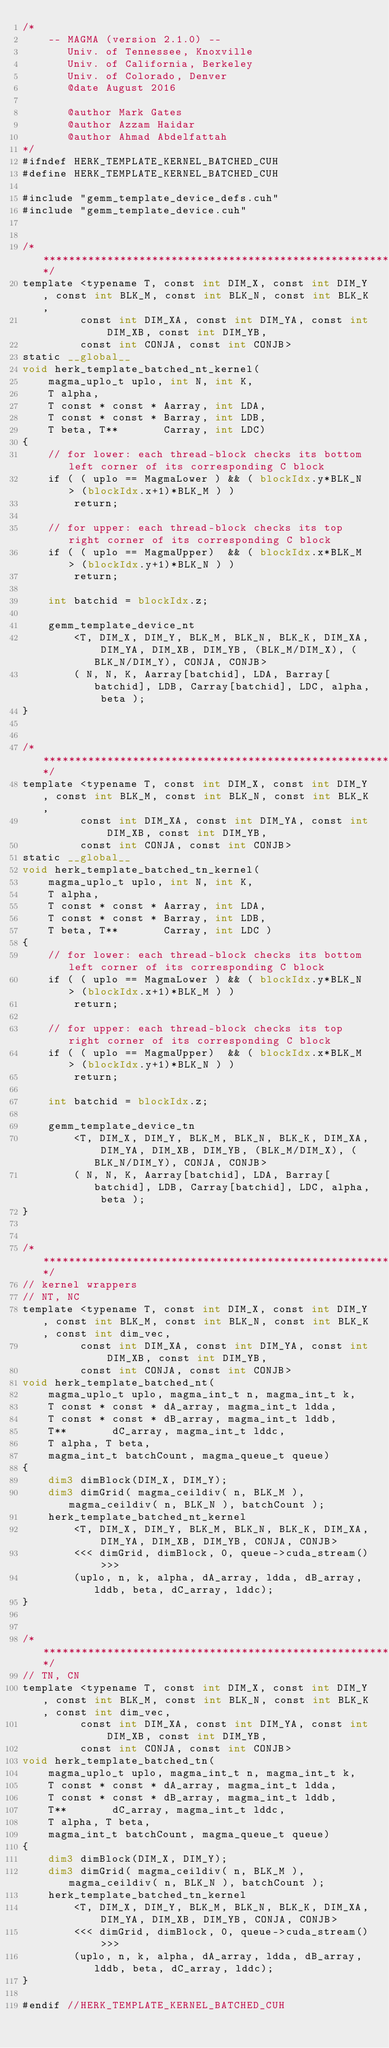<code> <loc_0><loc_0><loc_500><loc_500><_Cuda_>/*
    -- MAGMA (version 2.1.0) --
       Univ. of Tennessee, Knoxville
       Univ. of California, Berkeley
       Univ. of Colorado, Denver
       @date August 2016
       
       @author Mark Gates
       @author Azzam Haidar
       @author Ahmad Abdelfattah
*/
#ifndef HERK_TEMPLATE_KERNEL_BATCHED_CUH
#define HERK_TEMPLATE_KERNEL_BATCHED_CUH

#include "gemm_template_device_defs.cuh"
#include "gemm_template_device.cuh"


/******************************************************************************/
template <typename T, const int DIM_X, const int DIM_Y, const int BLK_M, const int BLK_N, const int BLK_K, 
         const int DIM_XA, const int DIM_YA, const int DIM_XB, const int DIM_YB, 
         const int CONJA, const int CONJB>
static __global__
void herk_template_batched_nt_kernel(
    magma_uplo_t uplo, int N, int K, 
    T alpha, 
    T const * const * Aarray, int LDA,
    T const * const * Barray, int LDB,
    T beta, T**       Carray, int LDC)
{
    // for lower: each thread-block checks its bottom left corner of its corresponding C block
    if ( ( uplo == MagmaLower ) && ( blockIdx.y*BLK_N > (blockIdx.x+1)*BLK_M ) )
        return;
    
    // for upper: each thread-block checks its top right corner of its corresponding C block
    if ( ( uplo == MagmaUpper)  && ( blockIdx.x*BLK_M > (blockIdx.y+1)*BLK_N ) )
        return;

    int batchid = blockIdx.z;
    
    gemm_template_device_nt
        <T, DIM_X, DIM_Y, BLK_M, BLK_N, BLK_K, DIM_XA, DIM_YA, DIM_XB, DIM_YB, (BLK_M/DIM_X), (BLK_N/DIM_Y), CONJA, CONJB>
        ( N, N, K, Aarray[batchid], LDA, Barray[batchid], LDB, Carray[batchid], LDC, alpha, beta );
}


/******************************************************************************/
template <typename T, const int DIM_X, const int DIM_Y, const int BLK_M, const int BLK_N, const int BLK_K, 
         const int DIM_XA, const int DIM_YA, const int DIM_XB, const int DIM_YB, 
         const int CONJA, const int CONJB>
static __global__
void herk_template_batched_tn_kernel(
    magma_uplo_t uplo, int N, int K, 
    T alpha, 
    T const * const * Aarray, int LDA,
    T const * const * Barray, int LDB,
    T beta, T**       Carray, int LDC )
{
    // for lower: each thread-block checks its bottom left corner of its corresponding C block
    if ( ( uplo == MagmaLower ) && ( blockIdx.y*BLK_N > (blockIdx.x+1)*BLK_M ) )
        return;
    
    // for upper: each thread-block checks its top right corner of its corresponding C block
    if ( ( uplo == MagmaUpper)  && ( blockIdx.x*BLK_M > (blockIdx.y+1)*BLK_N ) )
        return;

    int batchid = blockIdx.z;
    
    gemm_template_device_tn
        <T, DIM_X, DIM_Y, BLK_M, BLK_N, BLK_K, DIM_XA, DIM_YA, DIM_XB, DIM_YB, (BLK_M/DIM_X), (BLK_N/DIM_Y), CONJA, CONJB>
        ( N, N, K, Aarray[batchid], LDA, Barray[batchid], LDB, Carray[batchid], LDC, alpha, beta );
}


/******************************************************************************/
// kernel wrappers
// NT, NC 
template <typename T, const int DIM_X, const int DIM_Y, const int BLK_M, const int BLK_N, const int BLK_K, const int dim_vec, 
         const int DIM_XA, const int DIM_YA, const int DIM_XB, const int DIM_YB, 
         const int CONJA, const int CONJB>
void herk_template_batched_nt(
    magma_uplo_t uplo, magma_int_t n, magma_int_t k,
    T const * const * dA_array, magma_int_t ldda,
    T const * const * dB_array, magma_int_t lddb,
    T**       dC_array, magma_int_t lddc,
    T alpha, T beta,
    magma_int_t batchCount, magma_queue_t queue)
{
    dim3 dimBlock(DIM_X, DIM_Y);
    dim3 dimGrid( magma_ceildiv( n, BLK_M ), magma_ceildiv( n, BLK_N ), batchCount );
    herk_template_batched_nt_kernel
        <T, DIM_X, DIM_Y, BLK_M, BLK_N, BLK_K, DIM_XA, DIM_YA, DIM_XB, DIM_YB, CONJA, CONJB>
        <<< dimGrid, dimBlock, 0, queue->cuda_stream() >>>
        (uplo, n, k, alpha, dA_array, ldda, dB_array, lddb, beta, dC_array, lddc);
}


/******************************************************************************/
// TN, CN 
template <typename T, const int DIM_X, const int DIM_Y, const int BLK_M, const int BLK_N, const int BLK_K, const int dim_vec, 
         const int DIM_XA, const int DIM_YA, const int DIM_XB, const int DIM_YB, 
         const int CONJA, const int CONJB>
void herk_template_batched_tn(
    magma_uplo_t uplo, magma_int_t n, magma_int_t k,
    T const * const * dA_array, magma_int_t ldda,
    T const * const * dB_array, magma_int_t lddb,
    T**       dC_array, magma_int_t lddc,
    T alpha, T beta,
    magma_int_t batchCount, magma_queue_t queue)
{
    dim3 dimBlock(DIM_X, DIM_Y);
    dim3 dimGrid( magma_ceildiv( n, BLK_M ), magma_ceildiv( n, BLK_N ), batchCount );
    herk_template_batched_tn_kernel
        <T, DIM_X, DIM_Y, BLK_M, BLK_N, BLK_K, DIM_XA, DIM_YA, DIM_XB, DIM_YB, CONJA, CONJB>
        <<< dimGrid, dimBlock, 0, queue->cuda_stream() >>>
        (uplo, n, k, alpha, dA_array, ldda, dB_array, lddb, beta, dC_array, lddc);
}

#endif //HERK_TEMPLATE_KERNEL_BATCHED_CUH
</code> 